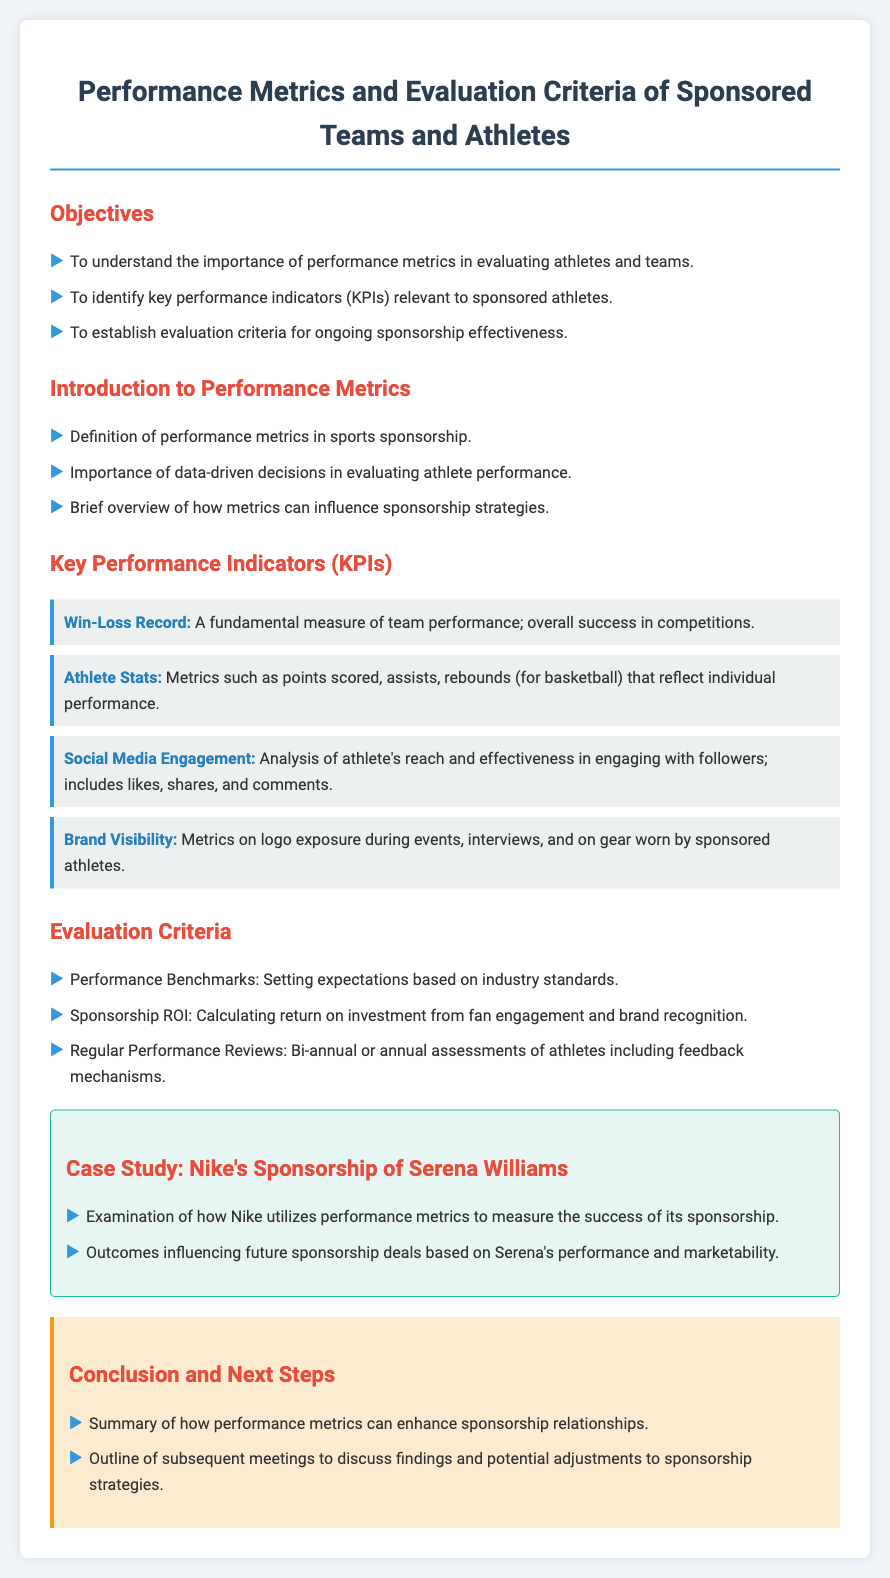What is the title of the document? The title of the document is found at the top, indicating the focus on performance metrics and criteria.
Answer: Performance Metrics and Evaluation Criteria of Sponsored Teams and Athletes What is one of the objectives mentioned? The document lists key objectives, one of which focuses on understanding the importance of performance metrics.
Answer: To understand the importance of performance metrics in evaluating athletes and teams What does the acronym KPI stand for? KPI appears several times in the document and stands for Key Performance Indicators.
Answer: Key Performance Indicators How often are performance reviews suggested? The document mentions a suggested timeframe for performance reviews.
Answer: Bi-annual or annual What is one example of a KPI provided? The document lists several KPIs, and one example indicates a basic measure of team success.
Answer: Win-Loss Record What case study is referenced in the document? The document presents a specific case study to illustrate sponsorship metrics in practice.
Answer: Nike's Sponsorship of Serena Williams What is a criterion for evaluating sponsorship effectiveness? The document includes specific evaluation criteria, one of which is focused on financial return.
Answer: Sponsorship ROI What type of engagement is analyzed for social media? The document discusses different forms of interaction with followers on social media.
Answer: Likes, shares, and comments What color is used for the conclusion section? The document uses specific colors throughout, and the conclusion section is identified by a certain background color.
Answer: #fdebd0 